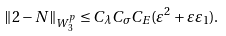Convert formula to latex. <formula><loc_0><loc_0><loc_500><loc_500>\| 2 - N \| _ { W _ { 3 } ^ { p } } \leq C _ { \lambda } C _ { \sigma } C _ { E } ( \varepsilon ^ { 2 } + \varepsilon \varepsilon _ { 1 } ) .</formula> 